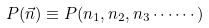Convert formula to latex. <formula><loc_0><loc_0><loc_500><loc_500>P ( \vec { n } ) \equiv P ( n _ { 1 } , n _ { 2 } , n _ { 3 } \cdots \cdots )</formula> 